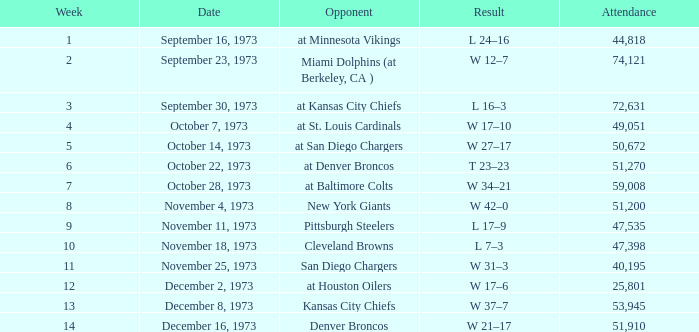What is the outcome after week 13? W 21–17. 